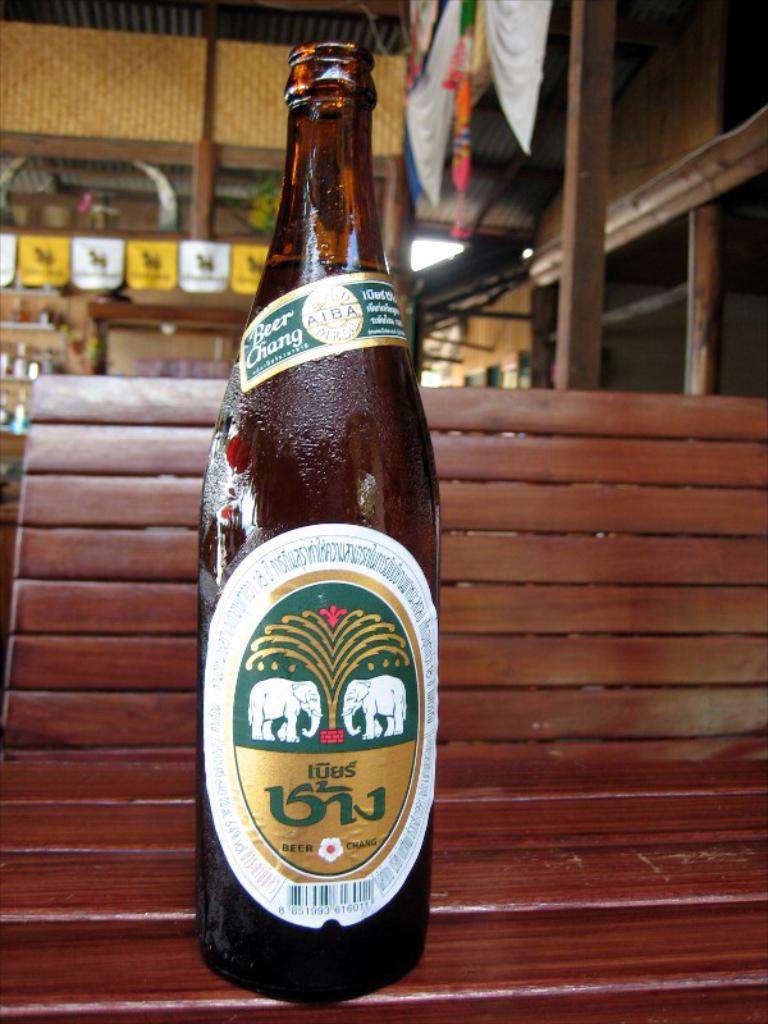What object is present on the table in the image? There is a bottle on the table in the image. What type of territory does the bat claim in the image? There is no bat present in the image, so it cannot claim any territory. 